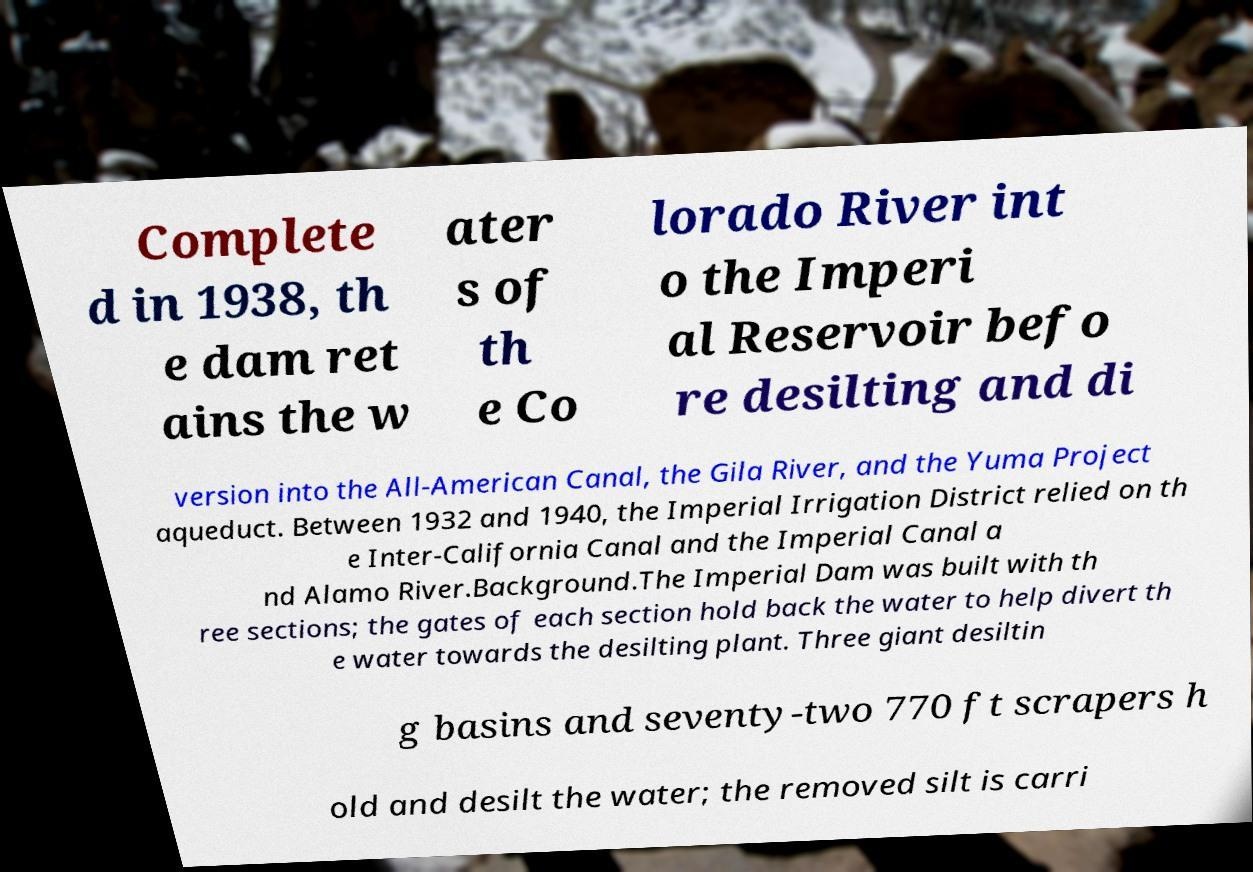Can you read and provide the text displayed in the image?This photo seems to have some interesting text. Can you extract and type it out for me? Complete d in 1938, th e dam ret ains the w ater s of th e Co lorado River int o the Imperi al Reservoir befo re desilting and di version into the All-American Canal, the Gila River, and the Yuma Project aqueduct. Between 1932 and 1940, the Imperial Irrigation District relied on th e Inter-California Canal and the Imperial Canal a nd Alamo River.Background.The Imperial Dam was built with th ree sections; the gates of each section hold back the water to help divert th e water towards the desilting plant. Three giant desiltin g basins and seventy-two 770 ft scrapers h old and desilt the water; the removed silt is carri 